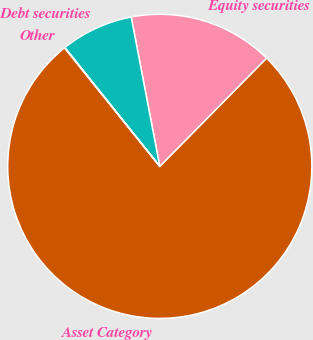<chart> <loc_0><loc_0><loc_500><loc_500><pie_chart><fcel>Asset Category<fcel>Equity securities<fcel>Debt securities<fcel>Other<nl><fcel>76.84%<fcel>15.4%<fcel>7.72%<fcel>0.04%<nl></chart> 